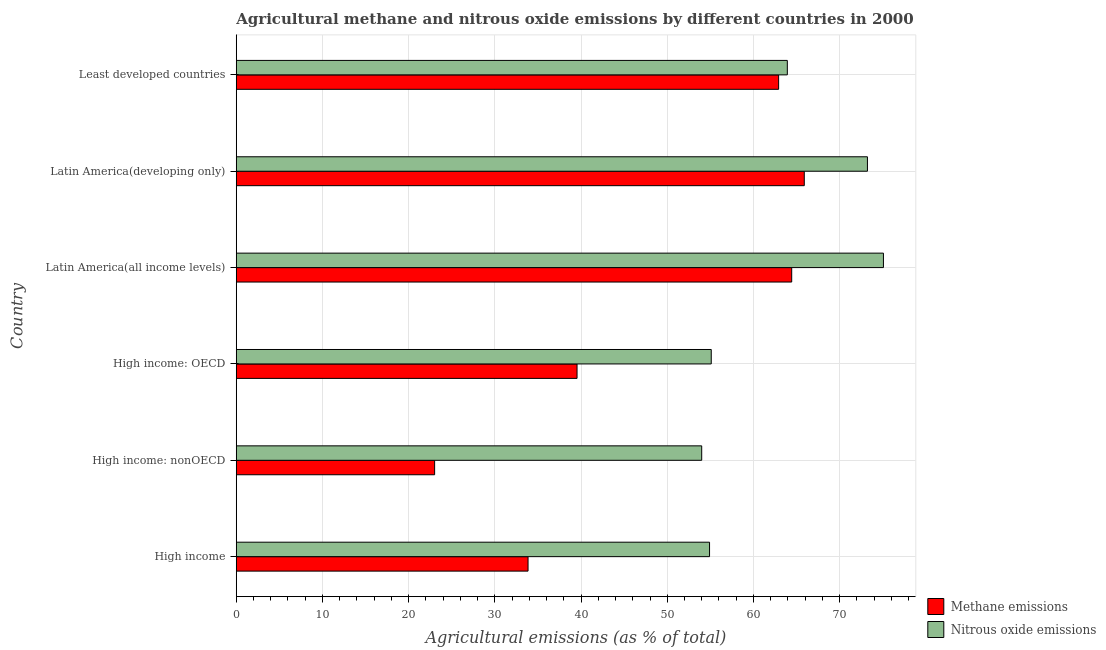How many different coloured bars are there?
Make the answer very short. 2. How many groups of bars are there?
Offer a terse response. 6. Are the number of bars per tick equal to the number of legend labels?
Ensure brevity in your answer.  Yes. Are the number of bars on each tick of the Y-axis equal?
Your answer should be compact. Yes. What is the label of the 4th group of bars from the top?
Make the answer very short. High income: OECD. What is the amount of nitrous oxide emissions in High income: nonOECD?
Offer a terse response. 54. Across all countries, what is the maximum amount of nitrous oxide emissions?
Your answer should be very brief. 75.08. Across all countries, what is the minimum amount of methane emissions?
Your answer should be compact. 23.01. In which country was the amount of methane emissions maximum?
Give a very brief answer. Latin America(developing only). In which country was the amount of nitrous oxide emissions minimum?
Ensure brevity in your answer.  High income: nonOECD. What is the total amount of nitrous oxide emissions in the graph?
Offer a terse response. 376.23. What is the difference between the amount of nitrous oxide emissions in High income: nonOECD and that in Least developed countries?
Give a very brief answer. -9.93. What is the difference between the amount of nitrous oxide emissions in High income and the amount of methane emissions in High income: OECD?
Your answer should be very brief. 15.37. What is the average amount of methane emissions per country?
Your response must be concise. 48.27. What is the difference between the amount of nitrous oxide emissions and amount of methane emissions in Latin America(all income levels)?
Give a very brief answer. 10.64. What is the ratio of the amount of methane emissions in High income to that in High income: OECD?
Offer a terse response. 0.86. What is the difference between the highest and the second highest amount of nitrous oxide emissions?
Offer a very short reply. 1.85. What is the difference between the highest and the lowest amount of methane emissions?
Offer a very short reply. 42.88. In how many countries, is the amount of nitrous oxide emissions greater than the average amount of nitrous oxide emissions taken over all countries?
Provide a succinct answer. 3. What does the 1st bar from the top in Least developed countries represents?
Offer a very short reply. Nitrous oxide emissions. What does the 2nd bar from the bottom in High income: OECD represents?
Provide a short and direct response. Nitrous oxide emissions. Does the graph contain any zero values?
Keep it short and to the point. No. How are the legend labels stacked?
Make the answer very short. Vertical. What is the title of the graph?
Make the answer very short. Agricultural methane and nitrous oxide emissions by different countries in 2000. Does "Public credit registry" appear as one of the legend labels in the graph?
Your answer should be compact. No. What is the label or title of the X-axis?
Give a very brief answer. Agricultural emissions (as % of total). What is the label or title of the Y-axis?
Make the answer very short. Country. What is the Agricultural emissions (as % of total) in Methane emissions in High income?
Ensure brevity in your answer.  33.85. What is the Agricultural emissions (as % of total) of Nitrous oxide emissions in High income?
Ensure brevity in your answer.  54.91. What is the Agricultural emissions (as % of total) of Methane emissions in High income: nonOECD?
Offer a terse response. 23.01. What is the Agricultural emissions (as % of total) of Nitrous oxide emissions in High income: nonOECD?
Give a very brief answer. 54. What is the Agricultural emissions (as % of total) in Methane emissions in High income: OECD?
Provide a succinct answer. 39.53. What is the Agricultural emissions (as % of total) of Nitrous oxide emissions in High income: OECD?
Provide a succinct answer. 55.1. What is the Agricultural emissions (as % of total) of Methane emissions in Latin America(all income levels)?
Your answer should be very brief. 64.44. What is the Agricultural emissions (as % of total) in Nitrous oxide emissions in Latin America(all income levels)?
Offer a very short reply. 75.08. What is the Agricultural emissions (as % of total) of Methane emissions in Latin America(developing only)?
Offer a very short reply. 65.9. What is the Agricultural emissions (as % of total) in Nitrous oxide emissions in Latin America(developing only)?
Ensure brevity in your answer.  73.22. What is the Agricultural emissions (as % of total) of Methane emissions in Least developed countries?
Offer a very short reply. 62.92. What is the Agricultural emissions (as % of total) of Nitrous oxide emissions in Least developed countries?
Your answer should be compact. 63.93. Across all countries, what is the maximum Agricultural emissions (as % of total) of Methane emissions?
Offer a terse response. 65.9. Across all countries, what is the maximum Agricultural emissions (as % of total) in Nitrous oxide emissions?
Your answer should be compact. 75.08. Across all countries, what is the minimum Agricultural emissions (as % of total) in Methane emissions?
Offer a very short reply. 23.01. Across all countries, what is the minimum Agricultural emissions (as % of total) in Nitrous oxide emissions?
Your response must be concise. 54. What is the total Agricultural emissions (as % of total) of Methane emissions in the graph?
Offer a terse response. 289.65. What is the total Agricultural emissions (as % of total) of Nitrous oxide emissions in the graph?
Your answer should be compact. 376.23. What is the difference between the Agricultural emissions (as % of total) of Methane emissions in High income and that in High income: nonOECD?
Offer a terse response. 10.84. What is the difference between the Agricultural emissions (as % of total) in Nitrous oxide emissions in High income and that in High income: nonOECD?
Make the answer very short. 0.91. What is the difference between the Agricultural emissions (as % of total) of Methane emissions in High income and that in High income: OECD?
Your answer should be very brief. -5.68. What is the difference between the Agricultural emissions (as % of total) of Nitrous oxide emissions in High income and that in High income: OECD?
Your answer should be compact. -0.2. What is the difference between the Agricultural emissions (as % of total) in Methane emissions in High income and that in Latin America(all income levels)?
Keep it short and to the point. -30.59. What is the difference between the Agricultural emissions (as % of total) of Nitrous oxide emissions in High income and that in Latin America(all income levels)?
Offer a terse response. -20.17. What is the difference between the Agricultural emissions (as % of total) of Methane emissions in High income and that in Latin America(developing only)?
Keep it short and to the point. -32.04. What is the difference between the Agricultural emissions (as % of total) in Nitrous oxide emissions in High income and that in Latin America(developing only)?
Keep it short and to the point. -18.32. What is the difference between the Agricultural emissions (as % of total) in Methane emissions in High income and that in Least developed countries?
Offer a very short reply. -29.07. What is the difference between the Agricultural emissions (as % of total) of Nitrous oxide emissions in High income and that in Least developed countries?
Provide a succinct answer. -9.02. What is the difference between the Agricultural emissions (as % of total) of Methane emissions in High income: nonOECD and that in High income: OECD?
Provide a succinct answer. -16.52. What is the difference between the Agricultural emissions (as % of total) in Nitrous oxide emissions in High income: nonOECD and that in High income: OECD?
Keep it short and to the point. -1.11. What is the difference between the Agricultural emissions (as % of total) in Methane emissions in High income: nonOECD and that in Latin America(all income levels)?
Your answer should be very brief. -41.43. What is the difference between the Agricultural emissions (as % of total) of Nitrous oxide emissions in High income: nonOECD and that in Latin America(all income levels)?
Offer a terse response. -21.08. What is the difference between the Agricultural emissions (as % of total) in Methane emissions in High income: nonOECD and that in Latin America(developing only)?
Offer a very short reply. -42.88. What is the difference between the Agricultural emissions (as % of total) of Nitrous oxide emissions in High income: nonOECD and that in Latin America(developing only)?
Give a very brief answer. -19.23. What is the difference between the Agricultural emissions (as % of total) in Methane emissions in High income: nonOECD and that in Least developed countries?
Offer a very short reply. -39.91. What is the difference between the Agricultural emissions (as % of total) in Nitrous oxide emissions in High income: nonOECD and that in Least developed countries?
Your answer should be very brief. -9.93. What is the difference between the Agricultural emissions (as % of total) in Methane emissions in High income: OECD and that in Latin America(all income levels)?
Provide a short and direct response. -24.9. What is the difference between the Agricultural emissions (as % of total) in Nitrous oxide emissions in High income: OECD and that in Latin America(all income levels)?
Keep it short and to the point. -19.97. What is the difference between the Agricultural emissions (as % of total) in Methane emissions in High income: OECD and that in Latin America(developing only)?
Give a very brief answer. -26.36. What is the difference between the Agricultural emissions (as % of total) of Nitrous oxide emissions in High income: OECD and that in Latin America(developing only)?
Ensure brevity in your answer.  -18.12. What is the difference between the Agricultural emissions (as % of total) of Methane emissions in High income: OECD and that in Least developed countries?
Offer a terse response. -23.38. What is the difference between the Agricultural emissions (as % of total) of Nitrous oxide emissions in High income: OECD and that in Least developed countries?
Your answer should be very brief. -8.82. What is the difference between the Agricultural emissions (as % of total) of Methane emissions in Latin America(all income levels) and that in Latin America(developing only)?
Make the answer very short. -1.46. What is the difference between the Agricultural emissions (as % of total) in Nitrous oxide emissions in Latin America(all income levels) and that in Latin America(developing only)?
Ensure brevity in your answer.  1.86. What is the difference between the Agricultural emissions (as % of total) in Methane emissions in Latin America(all income levels) and that in Least developed countries?
Give a very brief answer. 1.52. What is the difference between the Agricultural emissions (as % of total) in Nitrous oxide emissions in Latin America(all income levels) and that in Least developed countries?
Provide a short and direct response. 11.15. What is the difference between the Agricultural emissions (as % of total) in Methane emissions in Latin America(developing only) and that in Least developed countries?
Provide a succinct answer. 2.98. What is the difference between the Agricultural emissions (as % of total) of Nitrous oxide emissions in Latin America(developing only) and that in Least developed countries?
Offer a very short reply. 9.29. What is the difference between the Agricultural emissions (as % of total) in Methane emissions in High income and the Agricultural emissions (as % of total) in Nitrous oxide emissions in High income: nonOECD?
Offer a very short reply. -20.14. What is the difference between the Agricultural emissions (as % of total) in Methane emissions in High income and the Agricultural emissions (as % of total) in Nitrous oxide emissions in High income: OECD?
Keep it short and to the point. -21.25. What is the difference between the Agricultural emissions (as % of total) in Methane emissions in High income and the Agricultural emissions (as % of total) in Nitrous oxide emissions in Latin America(all income levels)?
Keep it short and to the point. -41.23. What is the difference between the Agricultural emissions (as % of total) of Methane emissions in High income and the Agricultural emissions (as % of total) of Nitrous oxide emissions in Latin America(developing only)?
Offer a very short reply. -39.37. What is the difference between the Agricultural emissions (as % of total) of Methane emissions in High income and the Agricultural emissions (as % of total) of Nitrous oxide emissions in Least developed countries?
Your answer should be very brief. -30.08. What is the difference between the Agricultural emissions (as % of total) of Methane emissions in High income: nonOECD and the Agricultural emissions (as % of total) of Nitrous oxide emissions in High income: OECD?
Make the answer very short. -32.09. What is the difference between the Agricultural emissions (as % of total) of Methane emissions in High income: nonOECD and the Agricultural emissions (as % of total) of Nitrous oxide emissions in Latin America(all income levels)?
Offer a terse response. -52.07. What is the difference between the Agricultural emissions (as % of total) of Methane emissions in High income: nonOECD and the Agricultural emissions (as % of total) of Nitrous oxide emissions in Latin America(developing only)?
Make the answer very short. -50.21. What is the difference between the Agricultural emissions (as % of total) of Methane emissions in High income: nonOECD and the Agricultural emissions (as % of total) of Nitrous oxide emissions in Least developed countries?
Your answer should be very brief. -40.92. What is the difference between the Agricultural emissions (as % of total) in Methane emissions in High income: OECD and the Agricultural emissions (as % of total) in Nitrous oxide emissions in Latin America(all income levels)?
Offer a very short reply. -35.54. What is the difference between the Agricultural emissions (as % of total) in Methane emissions in High income: OECD and the Agricultural emissions (as % of total) in Nitrous oxide emissions in Latin America(developing only)?
Ensure brevity in your answer.  -33.69. What is the difference between the Agricultural emissions (as % of total) of Methane emissions in High income: OECD and the Agricultural emissions (as % of total) of Nitrous oxide emissions in Least developed countries?
Offer a terse response. -24.39. What is the difference between the Agricultural emissions (as % of total) in Methane emissions in Latin America(all income levels) and the Agricultural emissions (as % of total) in Nitrous oxide emissions in Latin America(developing only)?
Ensure brevity in your answer.  -8.79. What is the difference between the Agricultural emissions (as % of total) of Methane emissions in Latin America(all income levels) and the Agricultural emissions (as % of total) of Nitrous oxide emissions in Least developed countries?
Offer a very short reply. 0.51. What is the difference between the Agricultural emissions (as % of total) of Methane emissions in Latin America(developing only) and the Agricultural emissions (as % of total) of Nitrous oxide emissions in Least developed countries?
Ensure brevity in your answer.  1.97. What is the average Agricultural emissions (as % of total) in Methane emissions per country?
Provide a short and direct response. 48.27. What is the average Agricultural emissions (as % of total) of Nitrous oxide emissions per country?
Offer a very short reply. 62.71. What is the difference between the Agricultural emissions (as % of total) in Methane emissions and Agricultural emissions (as % of total) in Nitrous oxide emissions in High income?
Your answer should be very brief. -21.06. What is the difference between the Agricultural emissions (as % of total) in Methane emissions and Agricultural emissions (as % of total) in Nitrous oxide emissions in High income: nonOECD?
Give a very brief answer. -30.98. What is the difference between the Agricultural emissions (as % of total) of Methane emissions and Agricultural emissions (as % of total) of Nitrous oxide emissions in High income: OECD?
Ensure brevity in your answer.  -15.57. What is the difference between the Agricultural emissions (as % of total) in Methane emissions and Agricultural emissions (as % of total) in Nitrous oxide emissions in Latin America(all income levels)?
Your response must be concise. -10.64. What is the difference between the Agricultural emissions (as % of total) of Methane emissions and Agricultural emissions (as % of total) of Nitrous oxide emissions in Latin America(developing only)?
Ensure brevity in your answer.  -7.33. What is the difference between the Agricultural emissions (as % of total) in Methane emissions and Agricultural emissions (as % of total) in Nitrous oxide emissions in Least developed countries?
Make the answer very short. -1.01. What is the ratio of the Agricultural emissions (as % of total) of Methane emissions in High income to that in High income: nonOECD?
Give a very brief answer. 1.47. What is the ratio of the Agricultural emissions (as % of total) in Nitrous oxide emissions in High income to that in High income: nonOECD?
Provide a short and direct response. 1.02. What is the ratio of the Agricultural emissions (as % of total) in Methane emissions in High income to that in High income: OECD?
Ensure brevity in your answer.  0.86. What is the ratio of the Agricultural emissions (as % of total) in Nitrous oxide emissions in High income to that in High income: OECD?
Your answer should be compact. 1. What is the ratio of the Agricultural emissions (as % of total) in Methane emissions in High income to that in Latin America(all income levels)?
Your response must be concise. 0.53. What is the ratio of the Agricultural emissions (as % of total) of Nitrous oxide emissions in High income to that in Latin America(all income levels)?
Keep it short and to the point. 0.73. What is the ratio of the Agricultural emissions (as % of total) in Methane emissions in High income to that in Latin America(developing only)?
Keep it short and to the point. 0.51. What is the ratio of the Agricultural emissions (as % of total) in Nitrous oxide emissions in High income to that in Latin America(developing only)?
Provide a short and direct response. 0.75. What is the ratio of the Agricultural emissions (as % of total) of Methane emissions in High income to that in Least developed countries?
Provide a succinct answer. 0.54. What is the ratio of the Agricultural emissions (as % of total) of Nitrous oxide emissions in High income to that in Least developed countries?
Offer a very short reply. 0.86. What is the ratio of the Agricultural emissions (as % of total) of Methane emissions in High income: nonOECD to that in High income: OECD?
Your answer should be very brief. 0.58. What is the ratio of the Agricultural emissions (as % of total) in Nitrous oxide emissions in High income: nonOECD to that in High income: OECD?
Your response must be concise. 0.98. What is the ratio of the Agricultural emissions (as % of total) of Methane emissions in High income: nonOECD to that in Latin America(all income levels)?
Make the answer very short. 0.36. What is the ratio of the Agricultural emissions (as % of total) in Nitrous oxide emissions in High income: nonOECD to that in Latin America(all income levels)?
Provide a succinct answer. 0.72. What is the ratio of the Agricultural emissions (as % of total) of Methane emissions in High income: nonOECD to that in Latin America(developing only)?
Provide a short and direct response. 0.35. What is the ratio of the Agricultural emissions (as % of total) of Nitrous oxide emissions in High income: nonOECD to that in Latin America(developing only)?
Provide a succinct answer. 0.74. What is the ratio of the Agricultural emissions (as % of total) in Methane emissions in High income: nonOECD to that in Least developed countries?
Your answer should be very brief. 0.37. What is the ratio of the Agricultural emissions (as % of total) of Nitrous oxide emissions in High income: nonOECD to that in Least developed countries?
Ensure brevity in your answer.  0.84. What is the ratio of the Agricultural emissions (as % of total) of Methane emissions in High income: OECD to that in Latin America(all income levels)?
Offer a terse response. 0.61. What is the ratio of the Agricultural emissions (as % of total) in Nitrous oxide emissions in High income: OECD to that in Latin America(all income levels)?
Give a very brief answer. 0.73. What is the ratio of the Agricultural emissions (as % of total) in Methane emissions in High income: OECD to that in Latin America(developing only)?
Your answer should be compact. 0.6. What is the ratio of the Agricultural emissions (as % of total) of Nitrous oxide emissions in High income: OECD to that in Latin America(developing only)?
Your answer should be very brief. 0.75. What is the ratio of the Agricultural emissions (as % of total) in Methane emissions in High income: OECD to that in Least developed countries?
Make the answer very short. 0.63. What is the ratio of the Agricultural emissions (as % of total) of Nitrous oxide emissions in High income: OECD to that in Least developed countries?
Your answer should be compact. 0.86. What is the ratio of the Agricultural emissions (as % of total) of Methane emissions in Latin America(all income levels) to that in Latin America(developing only)?
Your answer should be compact. 0.98. What is the ratio of the Agricultural emissions (as % of total) of Nitrous oxide emissions in Latin America(all income levels) to that in Latin America(developing only)?
Give a very brief answer. 1.03. What is the ratio of the Agricultural emissions (as % of total) of Methane emissions in Latin America(all income levels) to that in Least developed countries?
Provide a succinct answer. 1.02. What is the ratio of the Agricultural emissions (as % of total) in Nitrous oxide emissions in Latin America(all income levels) to that in Least developed countries?
Give a very brief answer. 1.17. What is the ratio of the Agricultural emissions (as % of total) in Methane emissions in Latin America(developing only) to that in Least developed countries?
Your response must be concise. 1.05. What is the ratio of the Agricultural emissions (as % of total) of Nitrous oxide emissions in Latin America(developing only) to that in Least developed countries?
Offer a very short reply. 1.15. What is the difference between the highest and the second highest Agricultural emissions (as % of total) in Methane emissions?
Give a very brief answer. 1.46. What is the difference between the highest and the second highest Agricultural emissions (as % of total) of Nitrous oxide emissions?
Ensure brevity in your answer.  1.86. What is the difference between the highest and the lowest Agricultural emissions (as % of total) in Methane emissions?
Make the answer very short. 42.88. What is the difference between the highest and the lowest Agricultural emissions (as % of total) in Nitrous oxide emissions?
Make the answer very short. 21.08. 